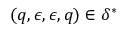<formula> <loc_0><loc_0><loc_500><loc_500>( q , \epsilon , \epsilon , q ) \in \delta ^ { * }</formula> 